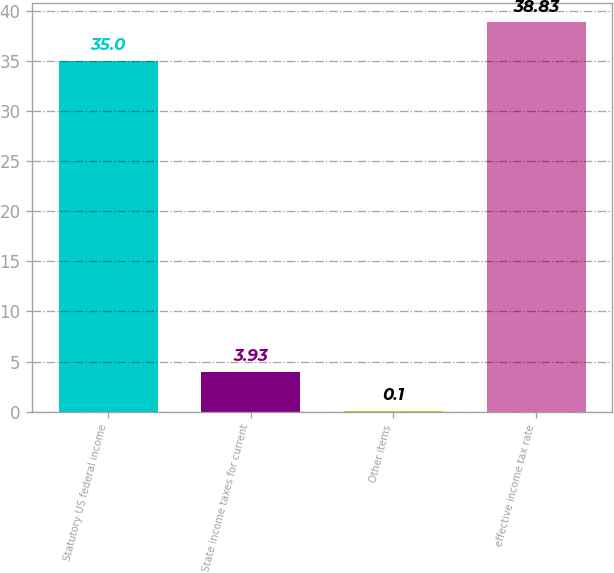<chart> <loc_0><loc_0><loc_500><loc_500><bar_chart><fcel>Statutory US federal income<fcel>State income taxes for current<fcel>Other items<fcel>effective income tax rate<nl><fcel>35<fcel>3.93<fcel>0.1<fcel>38.83<nl></chart> 